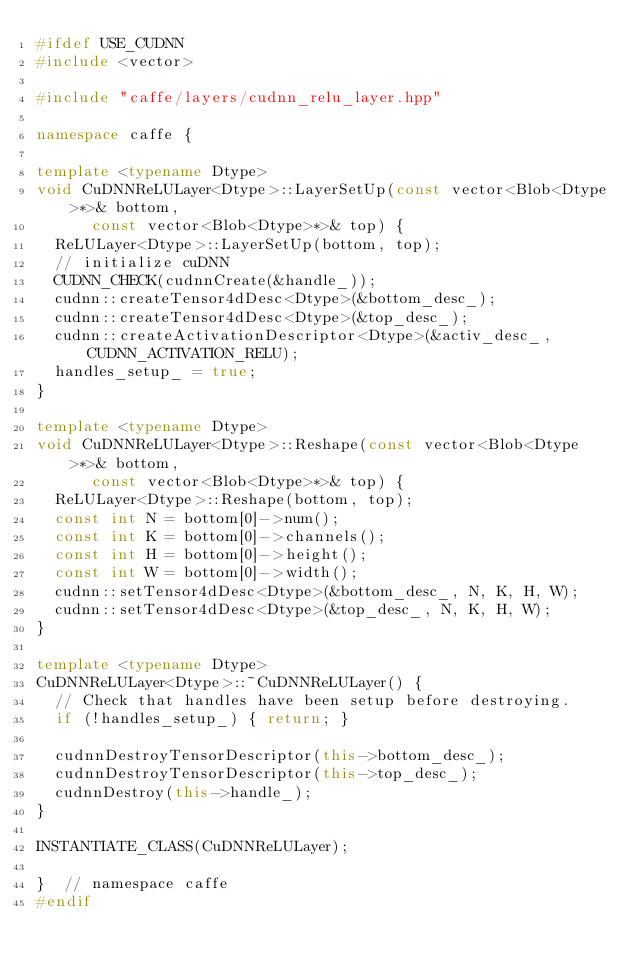Convert code to text. <code><loc_0><loc_0><loc_500><loc_500><_C++_>#ifdef USE_CUDNN
#include <vector>

#include "caffe/layers/cudnn_relu_layer.hpp"

namespace caffe {

template <typename Dtype>
void CuDNNReLULayer<Dtype>::LayerSetUp(const vector<Blob<Dtype>*>& bottom,
      const vector<Blob<Dtype>*>& top) {
  ReLULayer<Dtype>::LayerSetUp(bottom, top);
  // initialize cuDNN
  CUDNN_CHECK(cudnnCreate(&handle_));
  cudnn::createTensor4dDesc<Dtype>(&bottom_desc_);
  cudnn::createTensor4dDesc<Dtype>(&top_desc_);
  cudnn::createActivationDescriptor<Dtype>(&activ_desc_, CUDNN_ACTIVATION_RELU);
  handles_setup_ = true;
}

template <typename Dtype>
void CuDNNReLULayer<Dtype>::Reshape(const vector<Blob<Dtype>*>& bottom,
      const vector<Blob<Dtype>*>& top) {
  ReLULayer<Dtype>::Reshape(bottom, top);
  const int N = bottom[0]->num();
  const int K = bottom[0]->channels();
  const int H = bottom[0]->height();
  const int W = bottom[0]->width();
  cudnn::setTensor4dDesc<Dtype>(&bottom_desc_, N, K, H, W);
  cudnn::setTensor4dDesc<Dtype>(&top_desc_, N, K, H, W);
}

template <typename Dtype>
CuDNNReLULayer<Dtype>::~CuDNNReLULayer() {
  // Check that handles have been setup before destroying.
  if (!handles_setup_) { return; }

  cudnnDestroyTensorDescriptor(this->bottom_desc_);
  cudnnDestroyTensorDescriptor(this->top_desc_);
  cudnnDestroy(this->handle_);
}

INSTANTIATE_CLASS(CuDNNReLULayer);

}  // namespace caffe
#endif
</code> 